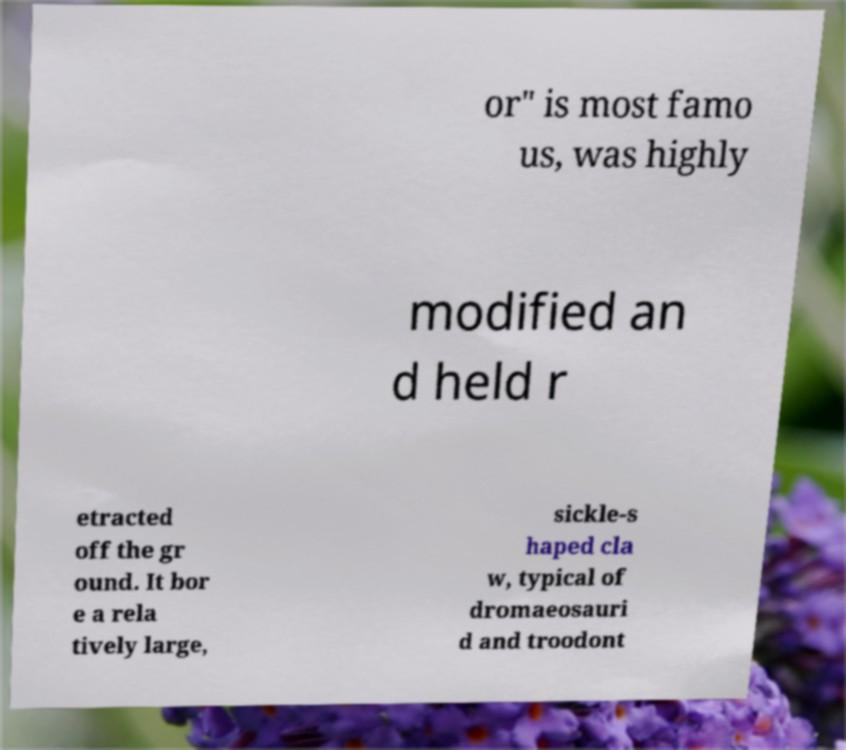Can you read and provide the text displayed in the image?This photo seems to have some interesting text. Can you extract and type it out for me? or" is most famo us, was highly modified an d held r etracted off the gr ound. It bor e a rela tively large, sickle-s haped cla w, typical of dromaeosauri d and troodont 